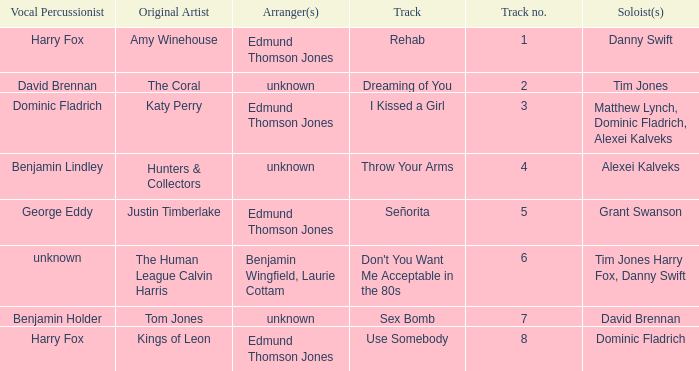Who is the original artist of "Use Somebody"? Kings of Leon. 